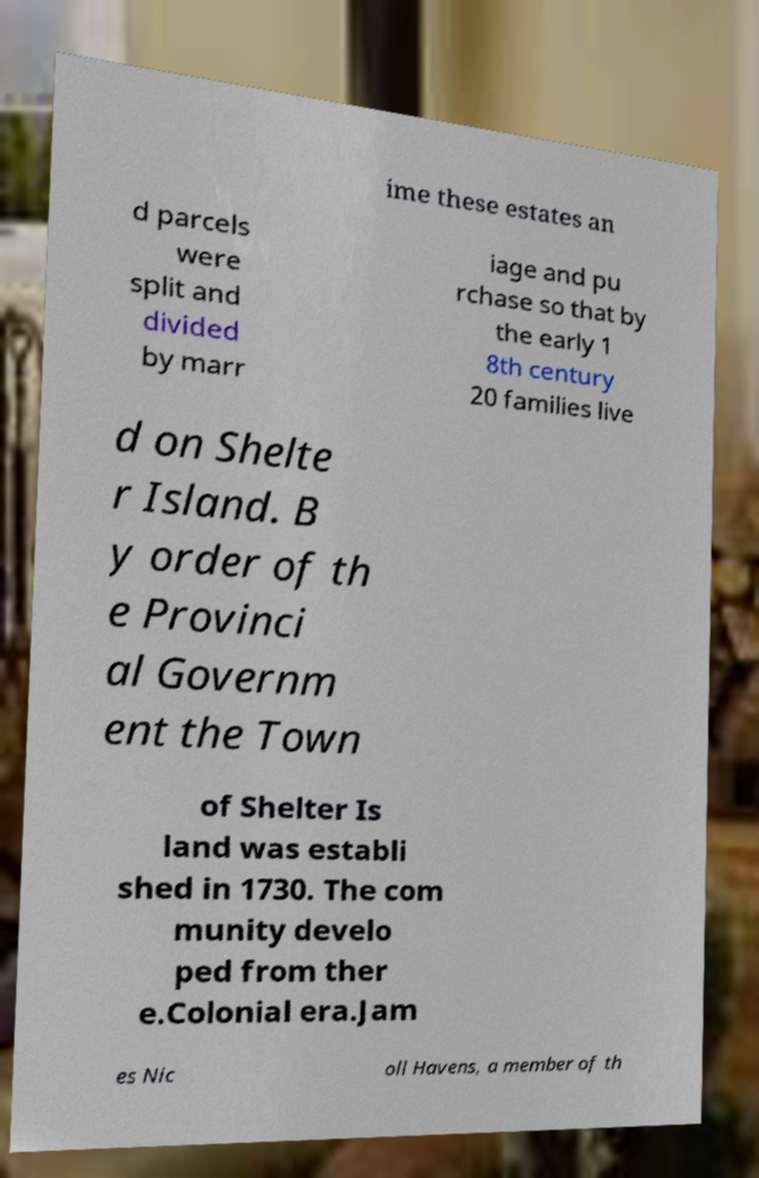What messages or text are displayed in this image? I need them in a readable, typed format. ime these estates an d parcels were split and divided by marr iage and pu rchase so that by the early 1 8th century 20 families live d on Shelte r Island. B y order of th e Provinci al Governm ent the Town of Shelter Is land was establi shed in 1730. The com munity develo ped from ther e.Colonial era.Jam es Nic oll Havens, a member of th 